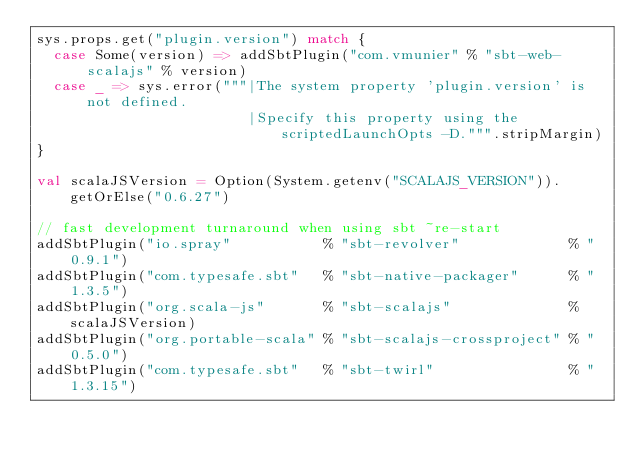<code> <loc_0><loc_0><loc_500><loc_500><_Scala_>sys.props.get("plugin.version") match {
  case Some(version) => addSbtPlugin("com.vmunier" % "sbt-web-scalajs" % version)
  case _ => sys.error("""|The system property 'plugin.version' is not defined.
                         |Specify this property using the scriptedLaunchOpts -D.""".stripMargin)
}

val scalaJSVersion = Option(System.getenv("SCALAJS_VERSION")).getOrElse("0.6.27")

// fast development turnaround when using sbt ~re-start
addSbtPlugin("io.spray"           % "sbt-revolver"             % "0.9.1")
addSbtPlugin("com.typesafe.sbt"   % "sbt-native-packager"      % "1.3.5")
addSbtPlugin("org.scala-js"       % "sbt-scalajs"              % scalaJSVersion)
addSbtPlugin("org.portable-scala" % "sbt-scalajs-crossproject" % "0.5.0")
addSbtPlugin("com.typesafe.sbt"   % "sbt-twirl"                % "1.3.15")
</code> 